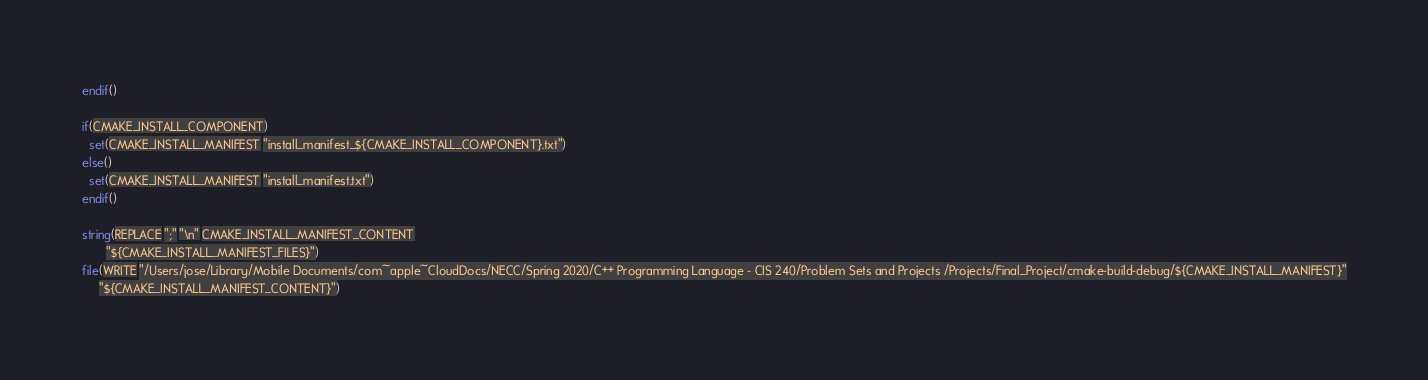Convert code to text. <code><loc_0><loc_0><loc_500><loc_500><_CMake_>endif()

if(CMAKE_INSTALL_COMPONENT)
  set(CMAKE_INSTALL_MANIFEST "install_manifest_${CMAKE_INSTALL_COMPONENT}.txt")
else()
  set(CMAKE_INSTALL_MANIFEST "install_manifest.txt")
endif()

string(REPLACE ";" "\n" CMAKE_INSTALL_MANIFEST_CONTENT
       "${CMAKE_INSTALL_MANIFEST_FILES}")
file(WRITE "/Users/jose/Library/Mobile Documents/com~apple~CloudDocs/NECC/Spring 2020/C++ Programming Language - CIS 240/Problem Sets and Projects /Projects/Final_Project/cmake-build-debug/${CMAKE_INSTALL_MANIFEST}"
     "${CMAKE_INSTALL_MANIFEST_CONTENT}")
</code> 